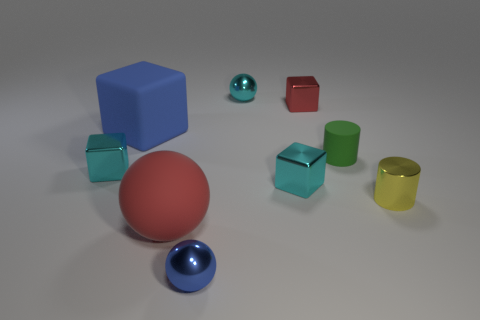Subtract all spheres. How many objects are left? 6 Subtract 1 cubes. How many cubes are left? 3 Subtract all red balls. Subtract all red cylinders. How many balls are left? 2 Subtract all cyan spheres. How many green cylinders are left? 1 Subtract all tiny gray metal spheres. Subtract all matte cubes. How many objects are left? 8 Add 5 metal cylinders. How many metal cylinders are left? 6 Add 1 tiny cyan rubber balls. How many tiny cyan rubber balls exist? 1 Subtract all blue cubes. How many cubes are left? 3 Subtract all blue cubes. How many cubes are left? 3 Subtract 0 cyan cylinders. How many objects are left? 9 